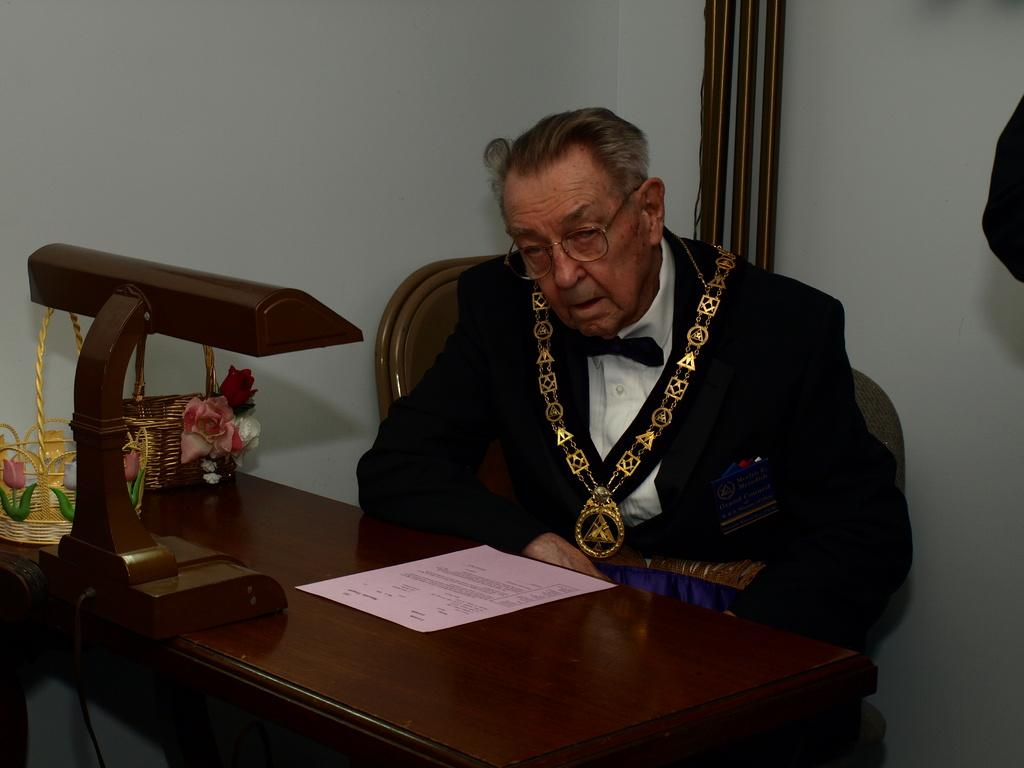What is the man in the image doing? The man is sitting on a chair in the image. What is in front of the man? There is a table in front of the man. What can be seen on the table? There are baskets, a paper, and a wooden stand on the table. Where is the grandmother sitting by the stream in the image? There is no grandmother or stream present in the image. 